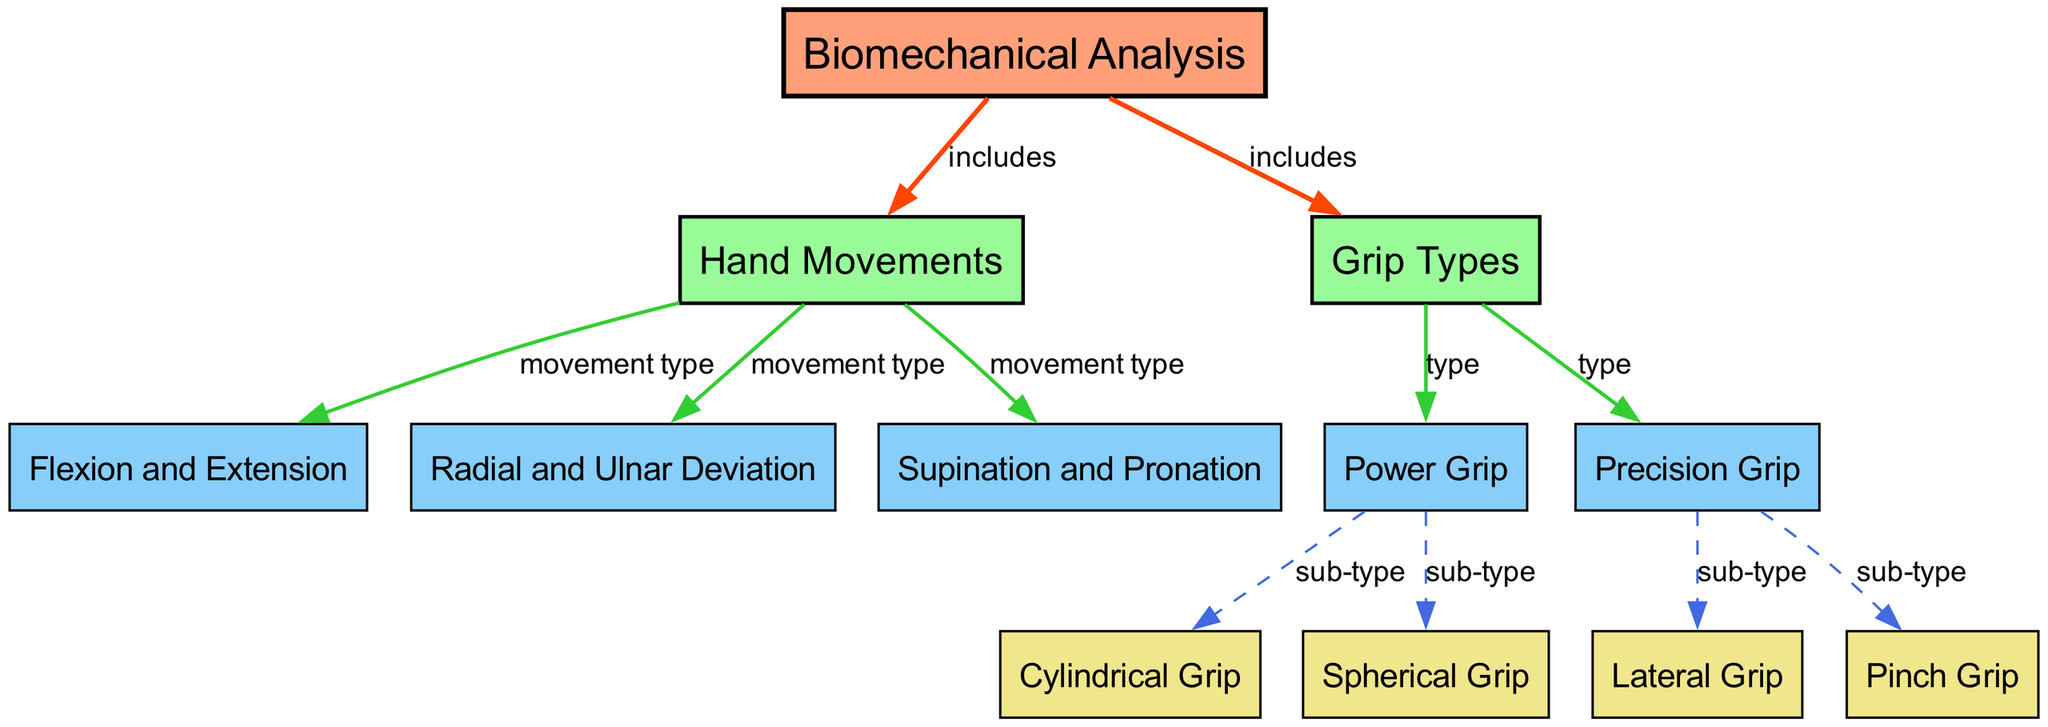What are the two main categories included in the biomechanical analysis? The diagram shows that "Hand Movements" and "Grip Types" are the two main categories that branch from "Biomechanical Analysis," as indicated by the edges connecting these nodes.
Answer: Hand Movements, Grip Types How many movement types are listed under hand movements? In the diagram, there are three edges connecting "Hand Movements" to "Flexion and Extension," "Radial and Ulnar Deviation," and "Supination and Pronation." This indicates that there are three recognized movement types under "Hand Movements."
Answer: 3 What sub-types are part of the power grip? The diagram indicates that "Power Grip" is connected to both "Cylindrical Grip" and "Spherical Grip" through dashed edges. These are classified as sub-types of the "Power Grip" in the diagram.
Answer: Cylindrical Grip, Spherical Grip Which grip type includes the lateral grip and pinch grip? The diagram shows that "Precision Grip" branches into "Lateral Grip" and "Pinch Grip." Therefore, the grip type that includes both of these is "Precision Grip."
Answer: Precision Grip What color represents the biomechanical analysis node in the diagram? The "Biomechanical Analysis" node, which is the top-level node in the diagram, is styled with a fill color of light salmon (#FFA07A). This specific color is used for highlighting the main concept of the diagram.
Answer: Light salmon How many total nodes are present in the diagram? The diagram consists of a total of 12 nodes, as indicated in the provided data. Each unique label, including "Biomechanical Analysis," "Hand Movements," "Grip Types," and others, counts as a separate node.
Answer: 12 From how many movement types can the hand movements be classified? In the diagram, "Hand Movements" are classified into three movement types: "Flexion and Extension," "Radial and Ulnar Deviation," and "Supination and Pronation." This is determined by examining the edges leading out from the "Hand Movements" node.
Answer: 3 